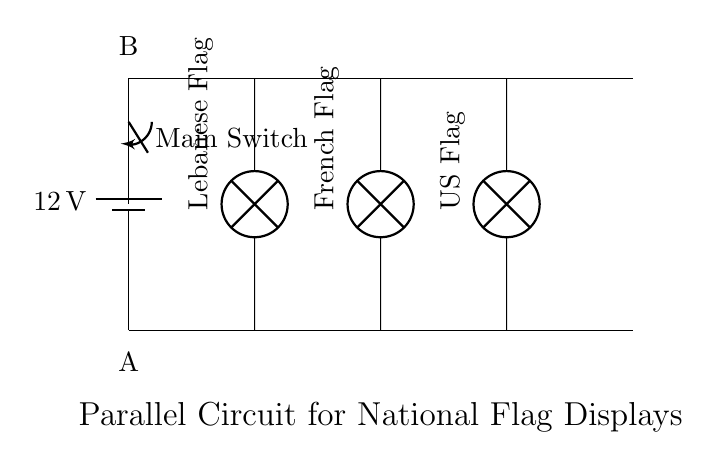What is the voltage supplied to the circuit? The circuit is powered by a battery labeled with twelve volts, which indicates the voltage supplied across the entire setup.
Answer: 12 volts What components are used to display the flags? The circuit diagram shows three lamps, each labeled with the names of the flags being displayed: Lebanese Flag, French Flag, and US Flag.
Answer: Three lamps How many branches does the circuit have? There are three connections from the main power line to the lamps, indicating three branches in the parallel circuit setup.
Answer: Three branches What is the role of the switch in this circuit? The switch, labeled "Main Switch," is used to control the power flow to all the flag displays. When closed, it allows current to pass through, lighting all the lamps.
Answer: Control power If one lamp burns out, what happens to the other lamps? In a parallel circuit, if one lamp fails, the others continue to function because each lamp operates independently on the same voltage supply.
Answer: They stay lit What type of circuit is used here? The configuration shows that each lamp is connected directly to the power supply, which characterizes the arrangement as a parallel circuit.
Answer: Parallel circuit 